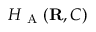<formula> <loc_0><loc_0><loc_500><loc_500>H _ { A } ( { R } , C )</formula> 